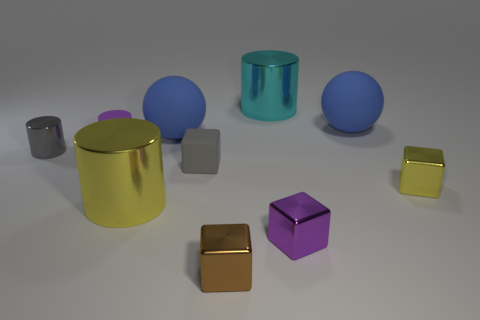Subtract all yellow blocks. How many blocks are left? 3 Subtract all yellow cylinders. How many cylinders are left? 3 Subtract 2 cylinders. How many cylinders are left? 2 Subtract all cubes. How many objects are left? 6 Add 2 big brown rubber things. How many big brown rubber things exist? 2 Subtract 1 yellow blocks. How many objects are left? 9 Subtract all purple balls. Subtract all green blocks. How many balls are left? 2 Subtract all gray matte cylinders. Subtract all small purple things. How many objects are left? 8 Add 8 large blue matte things. How many large blue matte things are left? 10 